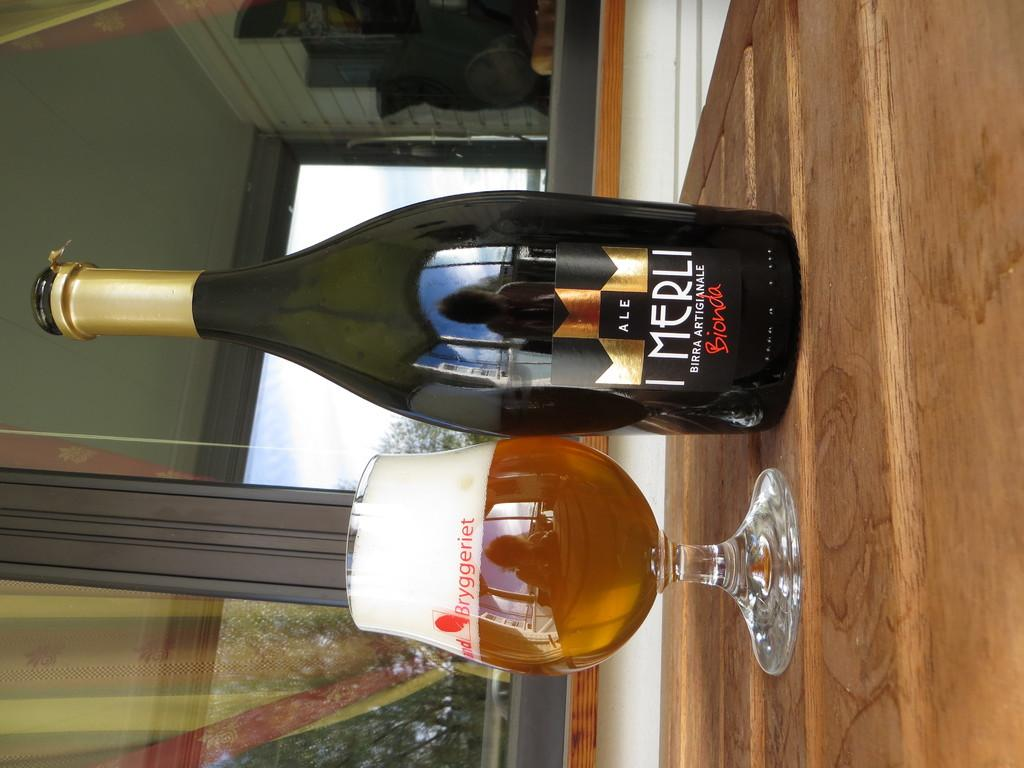Provide a one-sentence caption for the provided image. A bottle of Bionada Merli  ale sitting next to a glass half full of beer. 